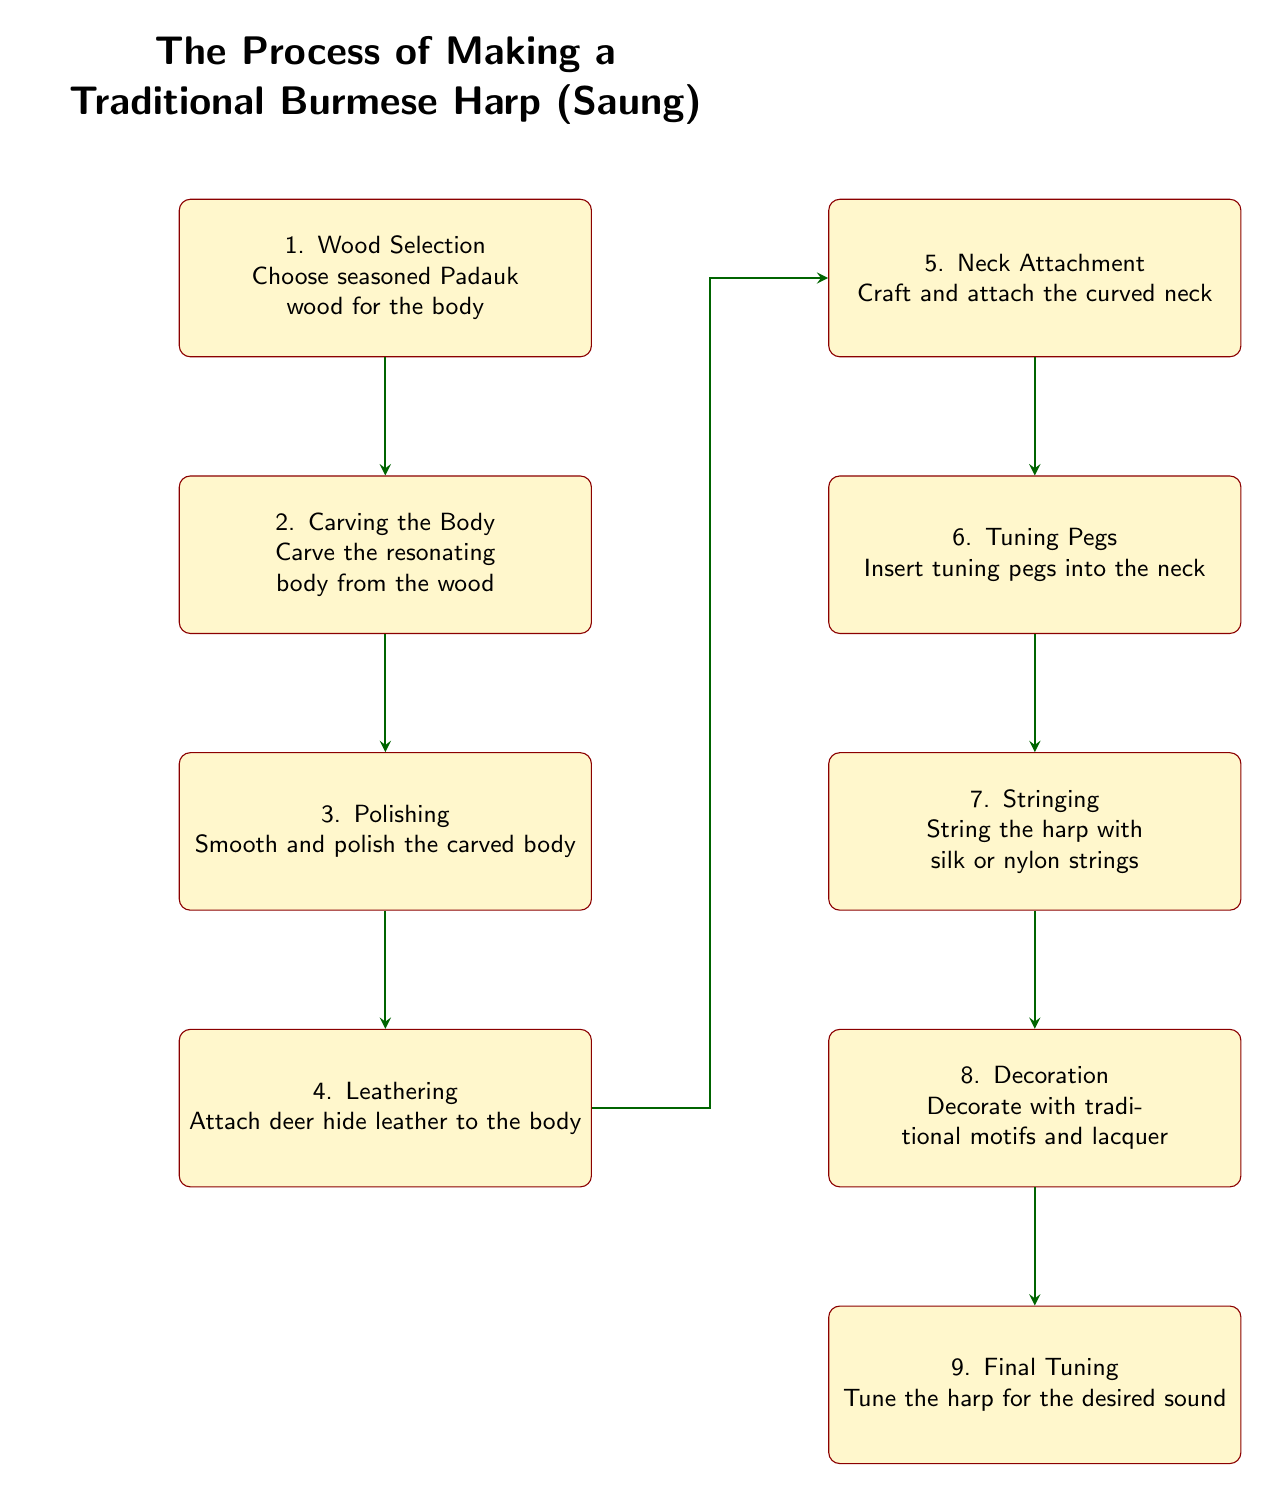What is the first step in making a traditional Burmese harp? The first step listed in the diagram is "Wood Selection." It indicates that the seasoned Padauk wood is chosen for the body.
Answer: Wood Selection How many steps are shown in the process of making the Saung? By counting the nodes in the diagram, there are a total of 9 steps illustrated in the process.
Answer: 9 What material is used for attaching to the body in the leathering step? The leathering step specifies that deer hide leather is attached to the body.
Answer: Deer hide leather Which step comes immediately after polishing? According to the flow of the diagram, the step that comes immediately after polishing is "Leathering."
Answer: Leathering What process attaches the curved neck to the body? The process of attaching the curved neck to the body is labeled as "Neck Attachment" in the diagram.
Answer: Neck Attachment What is the last step in the process? The final step indicated in the diagram is "Final Tuning," where the harp is tuned for the desired sound.
Answer: Final Tuning How do the steps "Carving the Body" and "Polishing" relate to each other? The diagram shows that "Carving the Body" is followed directly by "Polishing," indicating that polishing occurs after the body has been carved. The connection signifies a sequential relationship between these two steps.
Answer: Sequential relationship Which step involves inserting tuning pegs? The step that involves inserting tuning pegs into the neck is labeled as "Tuning Pegs" in the diagram.
Answer: Tuning Pegs What is added to the harp during the decoration step? The decoration step mentions that traditional motifs and lacquer are added to the harp.
Answer: Traditional motifs and lacquer 